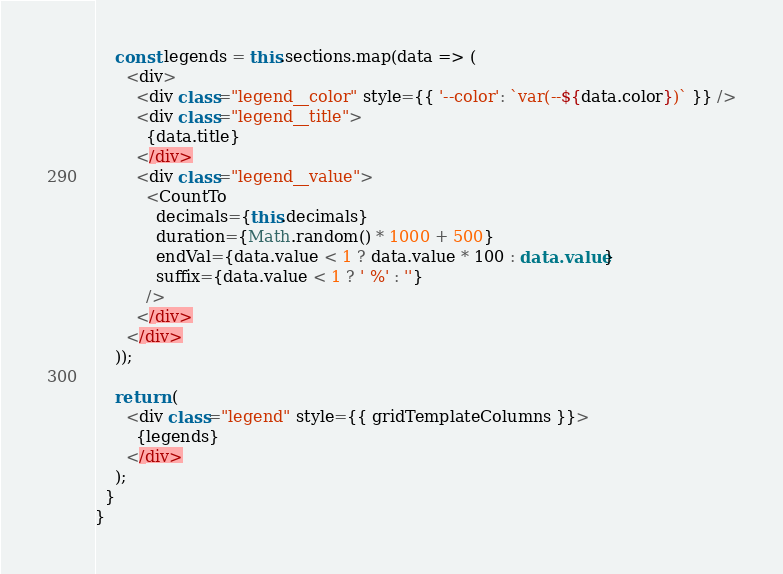<code> <loc_0><loc_0><loc_500><loc_500><_TypeScript_>
    const legends = this.sections.map(data => (
      <div>
        <div class="legend__color" style={{ '--color': `var(--${data.color})` }} />
        <div class="legend__title">
          {data.title}
        </div>
        <div class="legend__value">
          <CountTo
            decimals={this.decimals}
            duration={Math.random() * 1000 + 500}
            endVal={data.value < 1 ? data.value * 100 : data.value}
            suffix={data.value < 1 ? ' %' : ''}
          />
        </div>
      </div>
    ));

    return (
      <div class="legend" style={{ gridTemplateColumns }}>
        {legends}
      </div>
    );
  }
}
</code> 